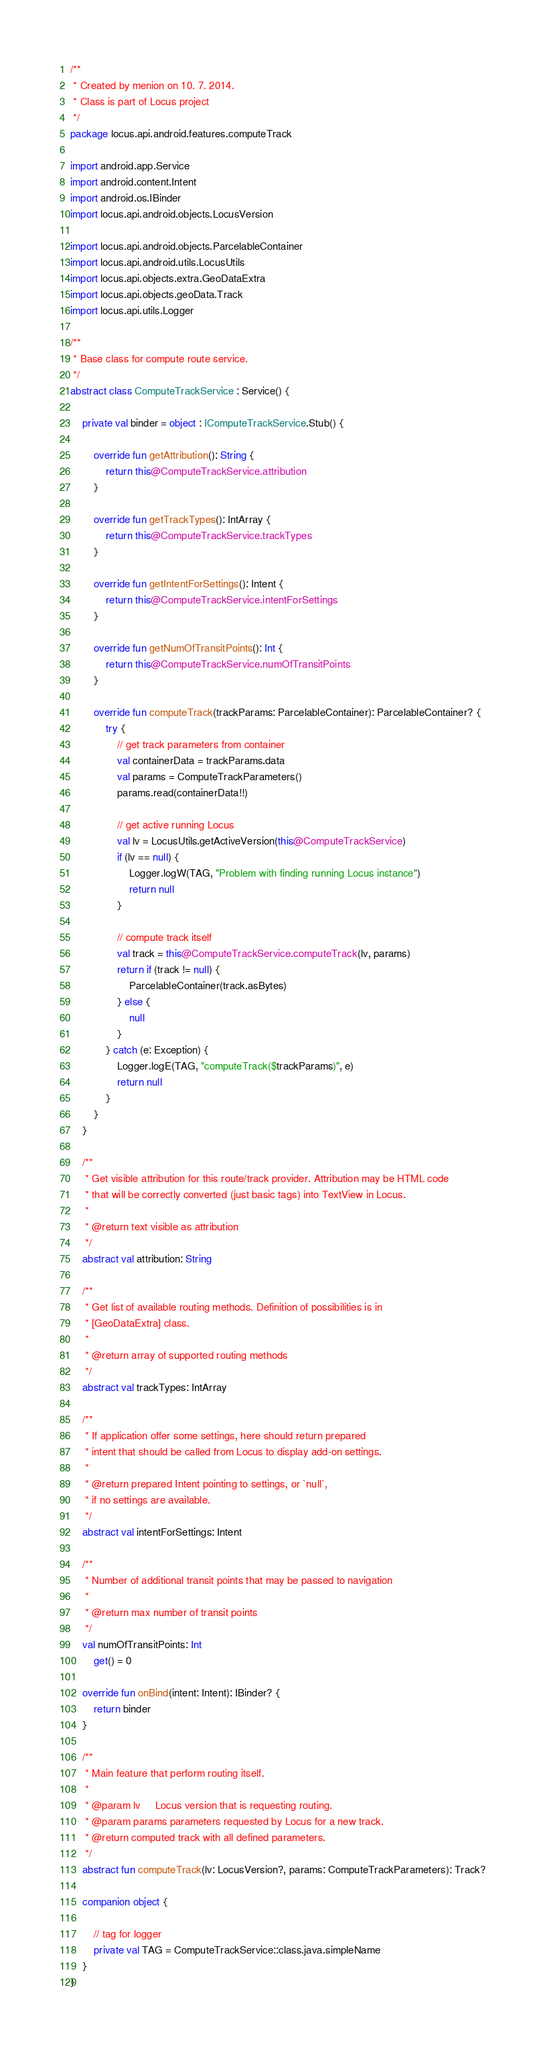Convert code to text. <code><loc_0><loc_0><loc_500><loc_500><_Kotlin_>/**
 * Created by menion on 10. 7. 2014.
 * Class is part of Locus project
 */
package locus.api.android.features.computeTrack

import android.app.Service
import android.content.Intent
import android.os.IBinder
import locus.api.android.objects.LocusVersion

import locus.api.android.objects.ParcelableContainer
import locus.api.android.utils.LocusUtils
import locus.api.objects.extra.GeoDataExtra
import locus.api.objects.geoData.Track
import locus.api.utils.Logger

/**
 * Base class for compute route service.
 */
abstract class ComputeTrackService : Service() {

    private val binder = object : IComputeTrackService.Stub() {

        override fun getAttribution(): String {
            return this@ComputeTrackService.attribution
        }

        override fun getTrackTypes(): IntArray {
            return this@ComputeTrackService.trackTypes
        }

        override fun getIntentForSettings(): Intent {
            return this@ComputeTrackService.intentForSettings
        }

        override fun getNumOfTransitPoints(): Int {
            return this@ComputeTrackService.numOfTransitPoints
        }

        override fun computeTrack(trackParams: ParcelableContainer): ParcelableContainer? {
            try {
                // get track parameters from container
                val containerData = trackParams.data
                val params = ComputeTrackParameters()
                params.read(containerData!!)

                // get active running Locus
                val lv = LocusUtils.getActiveVersion(this@ComputeTrackService)
                if (lv == null) {
                    Logger.logW(TAG, "Problem with finding running Locus instance")
                    return null
                }

                // compute track itself
                val track = this@ComputeTrackService.computeTrack(lv, params)
                return if (track != null) {
                    ParcelableContainer(track.asBytes)
                } else {
                    null
                }
            } catch (e: Exception) {
                Logger.logE(TAG, "computeTrack($trackParams)", e)
                return null
            }
        }
    }

    /**
     * Get visible attribution for this route/track provider. Attribution may be HTML code
     * that will be correctly converted (just basic tags) into TextView in Locus.
     *
     * @return text visible as attribution
     */
    abstract val attribution: String

    /**
     * Get list of available routing methods. Definition of possibilities is in
     * [GeoDataExtra] class.
     *
     * @return array of supported routing methods
     */
    abstract val trackTypes: IntArray

    /**
     * If application offer some settings, here should return prepared
     * intent that should be called from Locus to display add-on settings.
     *
     * @return prepared Intent pointing to settings, or `null`,
     * if no settings are available.
     */
    abstract val intentForSettings: Intent

    /**
     * Number of additional transit points that may be passed to navigation
     *
     * @return max number of transit points
     */
    val numOfTransitPoints: Int
        get() = 0

    override fun onBind(intent: Intent): IBinder? {
        return binder
    }

    /**
     * Main feature that perform routing itself.
     *
     * @param lv     Locus version that is requesting routing.
     * @param params parameters requested by Locus for a new track.
     * @return computed track with all defined parameters.
     */
    abstract fun computeTrack(lv: LocusVersion?, params: ComputeTrackParameters): Track?

    companion object {

        // tag for logger
        private val TAG = ComputeTrackService::class.java.simpleName
    }
}
</code> 